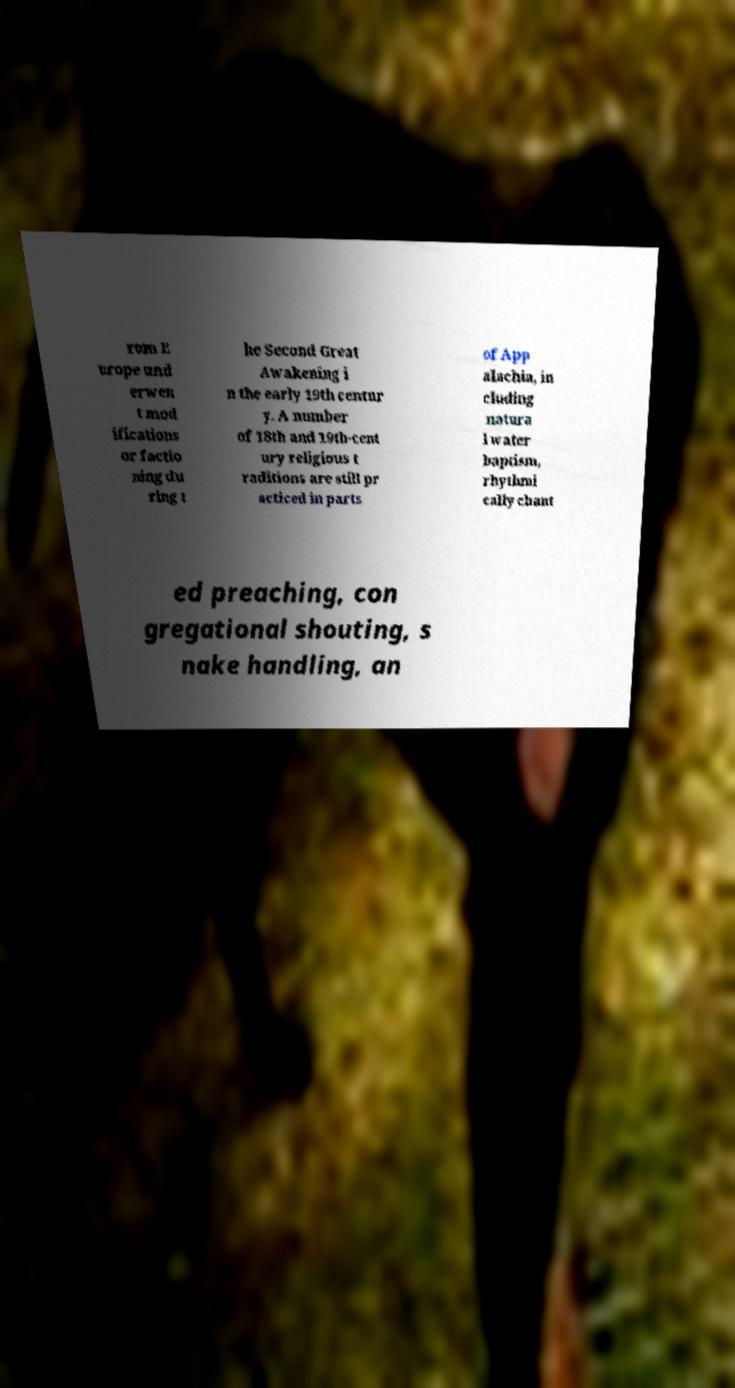Can you read and provide the text displayed in the image?This photo seems to have some interesting text. Can you extract and type it out for me? rom E urope und erwen t mod ifications or factio ning du ring t he Second Great Awakening i n the early 19th centur y. A number of 18th and 19th-cent ury religious t raditions are still pr acticed in parts of App alachia, in cluding natura l water baptism, rhythmi cally chant ed preaching, con gregational shouting, s nake handling, an 